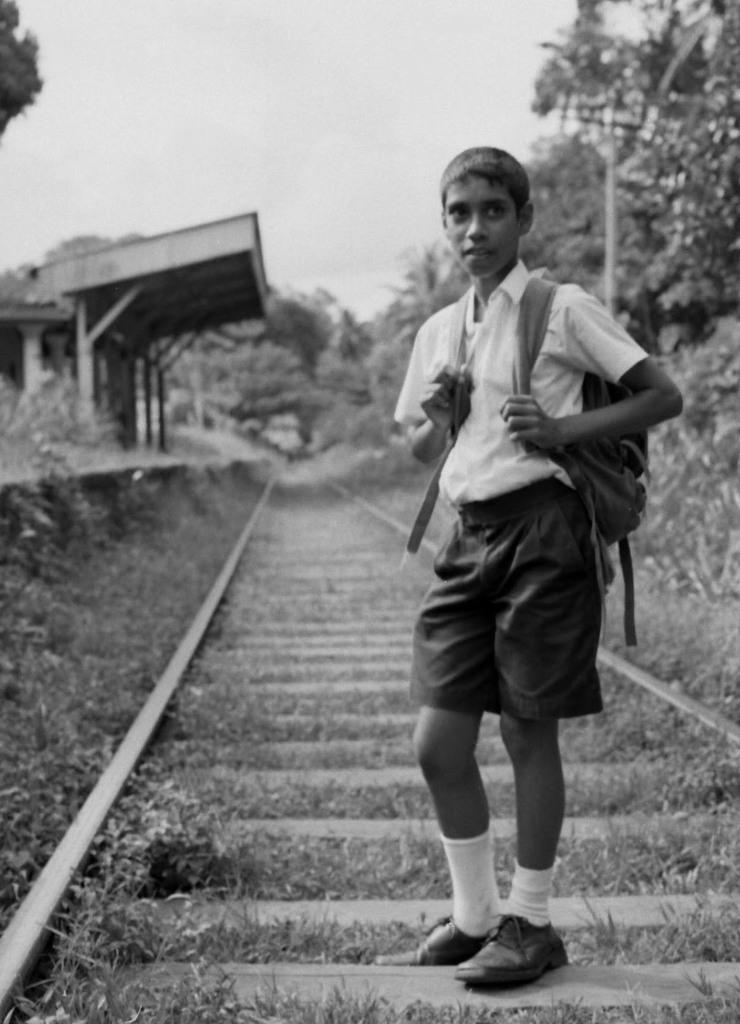How would you summarize this image in a sentence or two? In the image we can see a boy standing, wearing clothes, socks and shoes, and hanging a bag on his back. There are train tracks, grass, trees, pole and a sky, this is a station. 